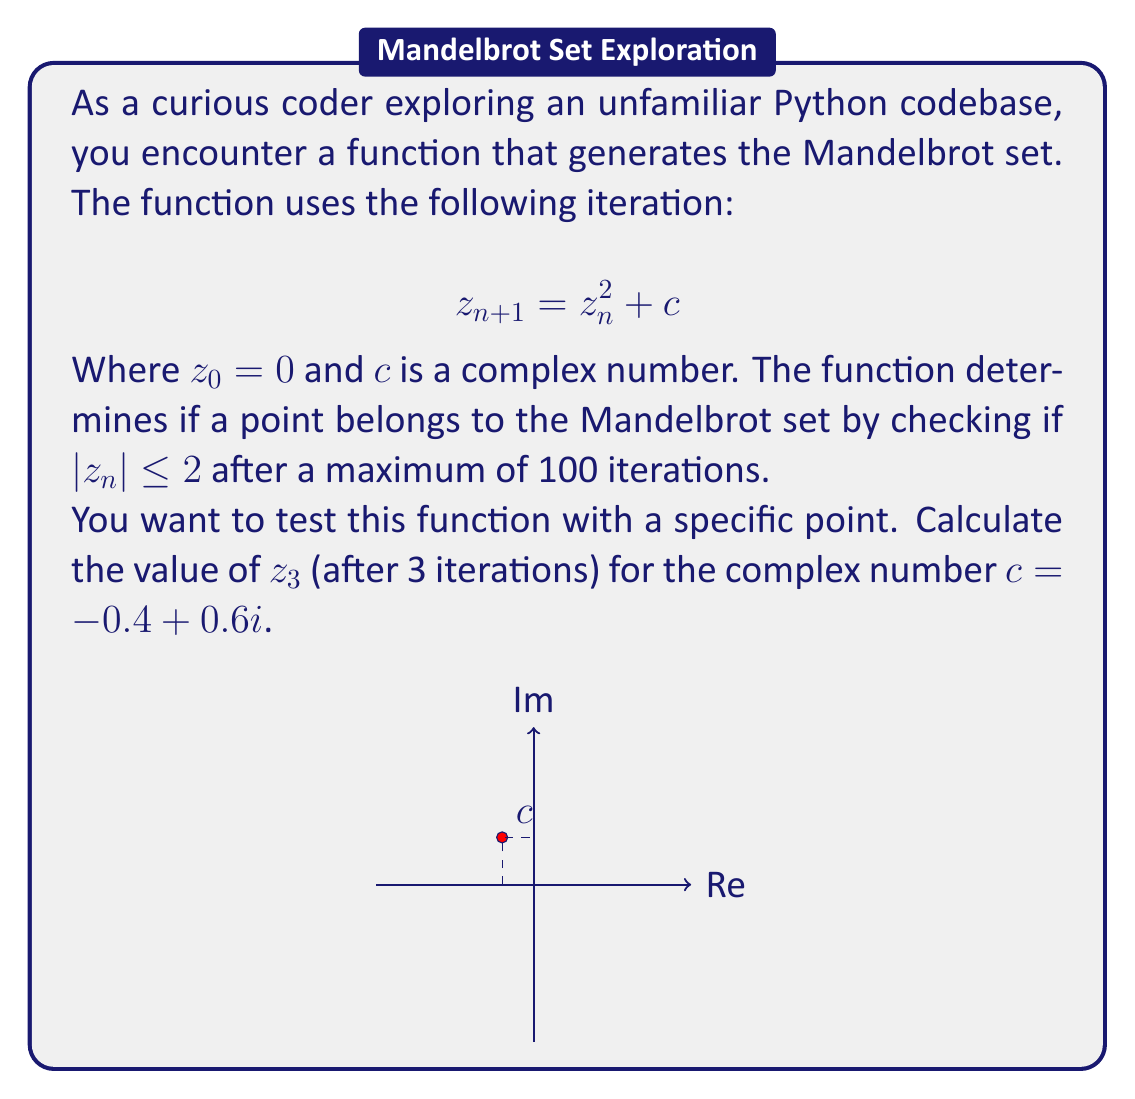Teach me how to tackle this problem. Let's calculate $z_3$ step by step:

1) We start with $z_0 = 0$ and $c = -0.4 + 0.6i$

2) First iteration ($n = 0$):
   $z_1 = z_0^2 + c = 0^2 + (-0.4 + 0.6i) = -0.4 + 0.6i$

3) Second iteration ($n = 1$):
   $z_2 = z_1^2 + c$
   $= (-0.4 + 0.6i)^2 + (-0.4 + 0.6i)$
   $= (0.16 - 0.48i - 0.36) + (-0.4 + 0.6i)$
   $= -0.2 - 0.48i + (-0.4 + 0.6i)$
   $= -0.6 + 0.12i$

4) Third iteration ($n = 2$):
   $z_3 = z_2^2 + c$
   $= (-0.6 + 0.12i)^2 + (-0.4 + 0.6i)$
   $= (0.36 - 0.144i - 0.0144) + (-0.4 + 0.6i)$
   $= 0.3456 - 0.144i + (-0.4 + 0.6i)$
   $= -0.0544 + 0.456i$

Therefore, after 3 iterations, $z_3 = -0.0544 + 0.456i$
Answer: $-0.0544 + 0.456i$ 